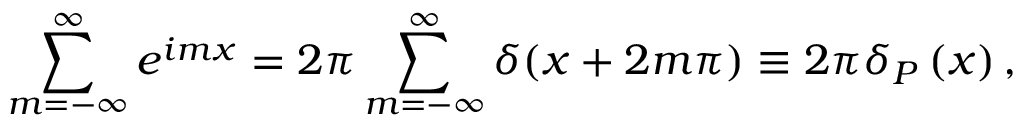Convert formula to latex. <formula><loc_0><loc_0><loc_500><loc_500>\sum _ { m = - \infty } ^ { \infty } e ^ { i m x } = 2 \pi \sum _ { m = - \infty } ^ { \infty } \delta ( x + 2 m \pi ) \equiv 2 \pi \delta _ { P } \left ( x \right ) ,</formula> 